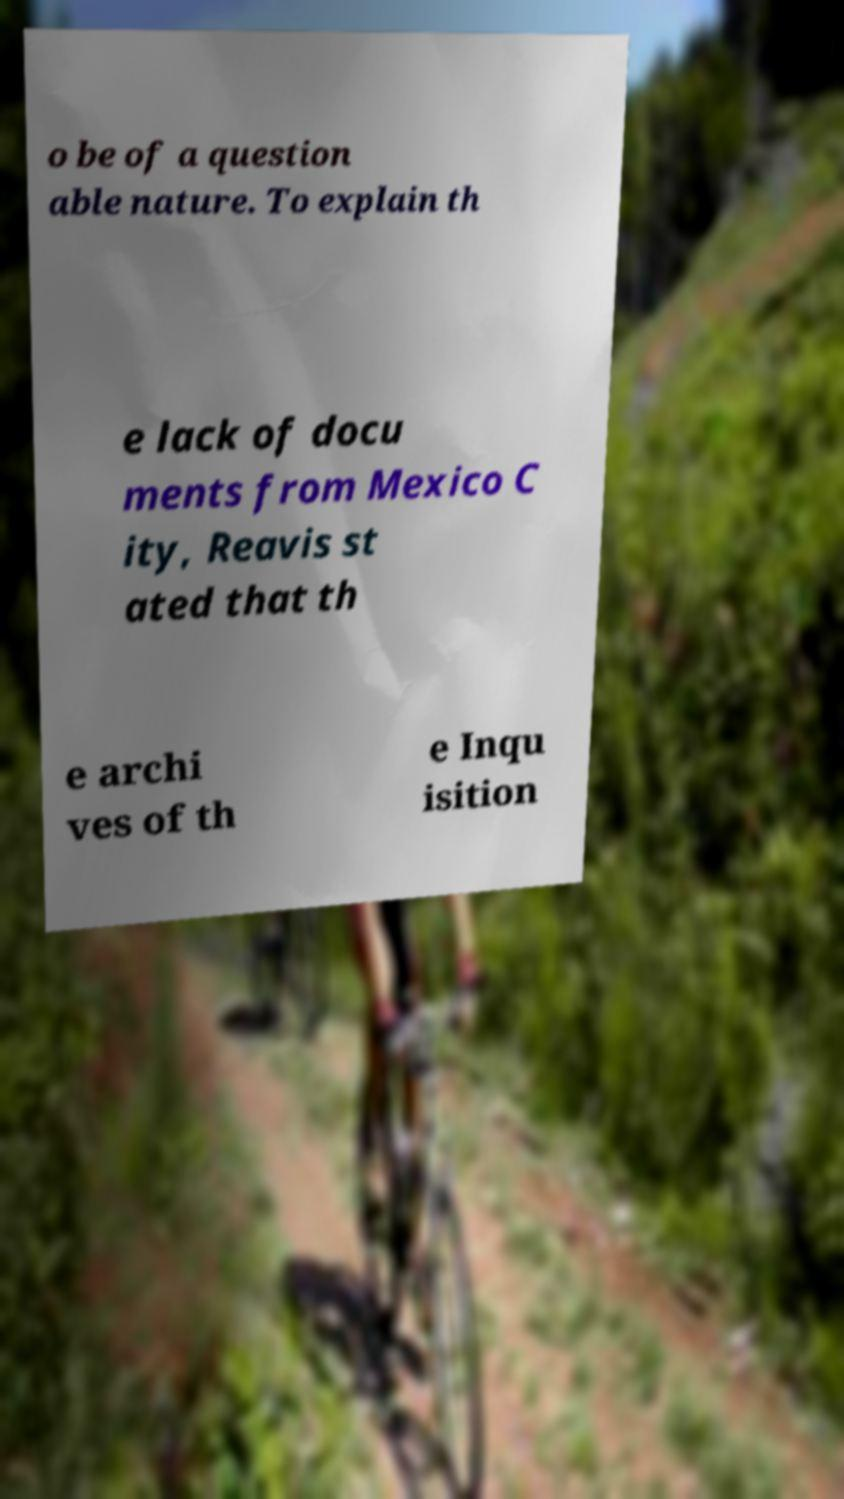For documentation purposes, I need the text within this image transcribed. Could you provide that? o be of a question able nature. To explain th e lack of docu ments from Mexico C ity, Reavis st ated that th e archi ves of th e Inqu isition 